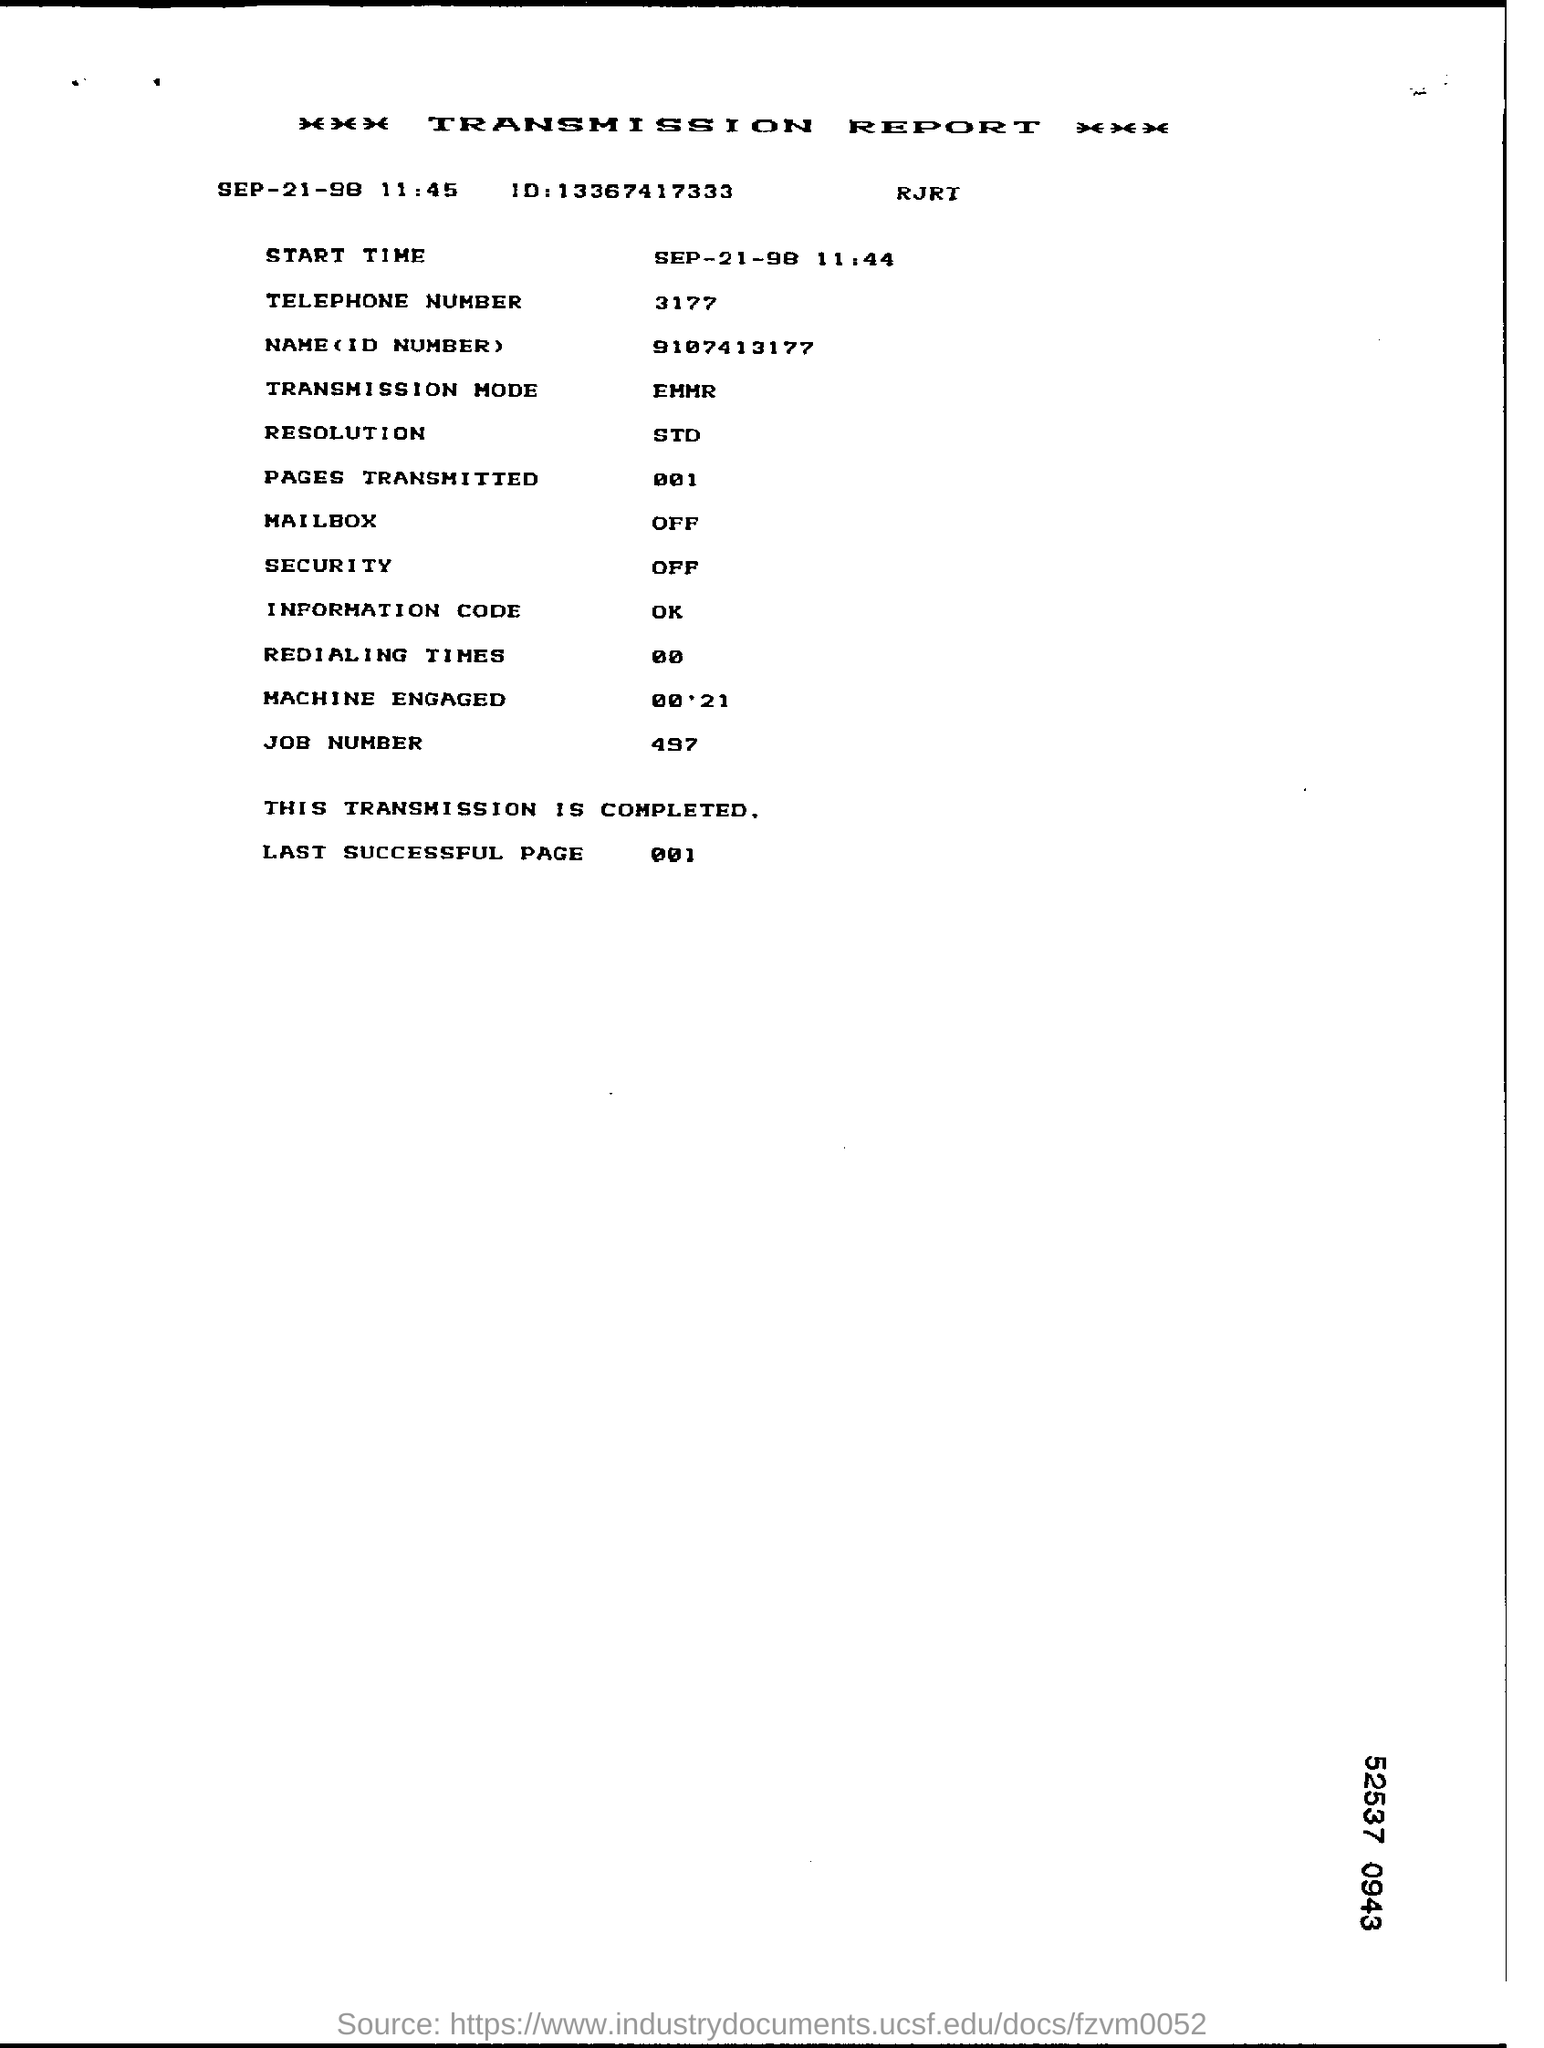What does the existing 'Transmission Mode' imply about the quality or speed of the data transmission? The 'Transmission Mode' labeled as 'EMHR' typically refers to a specific method used for sending the data. While the exact meaning can vary, generally, such specifications affect how efficiently and securely the information is transmitted, potentially impacting both speed and quality of the data transfer. 